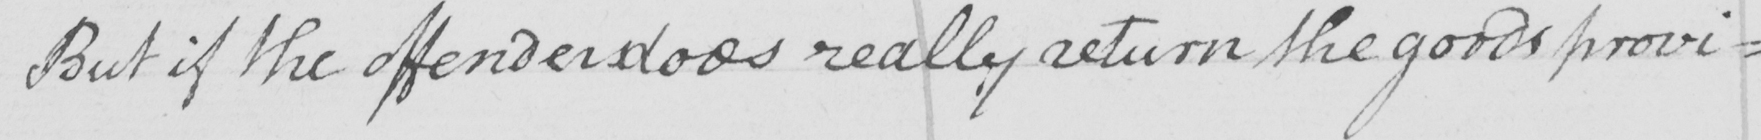What is written in this line of handwriting? But if the offender does really return the goods provi= 